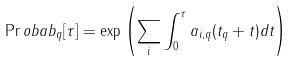Convert formula to latex. <formula><loc_0><loc_0><loc_500><loc_500>\Pr o b a b _ { q } [ \tau ] = \exp \left ( \sum _ { i } \int _ { 0 } ^ { \tau } { a _ { i , q } ( t _ { q } + t ) d t } \right )</formula> 